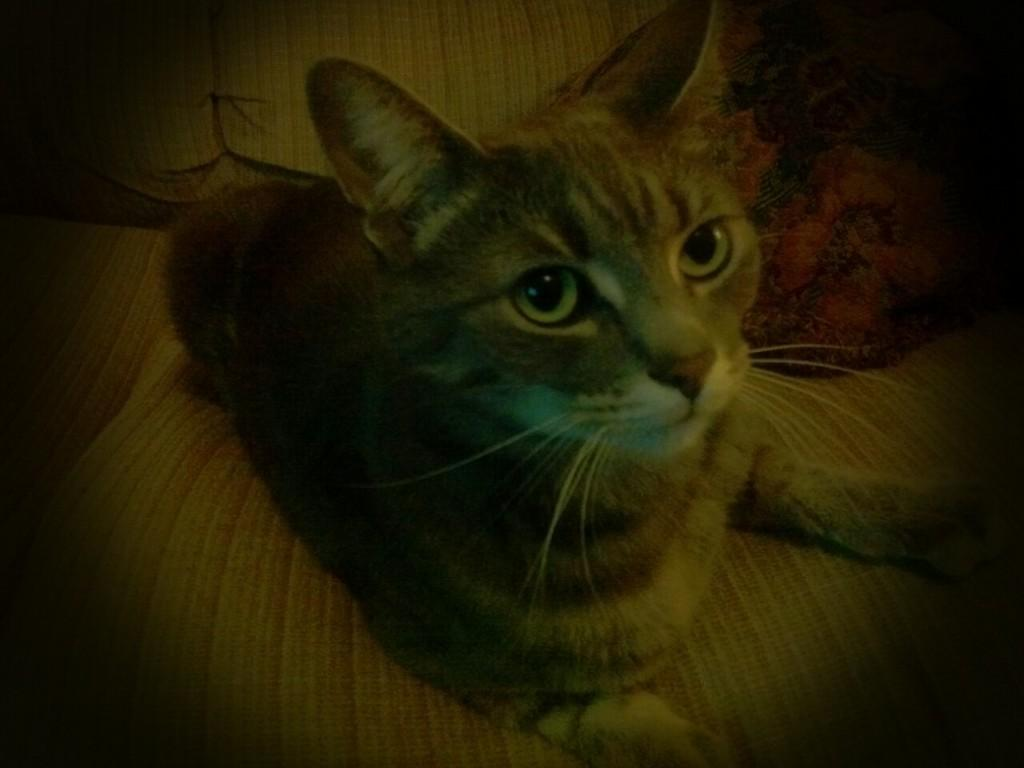What animal is in the picture? There is a cat in the picture. Where is the cat located? The cat is sitting on a couch. What else can be seen near the cat? There are pillows beside the cat. How many snakes are slithering on the floor in the image? There are no snakes present in the image; it features a cat sitting on a couch with pillows nearby. What type of picture is hanging on the wall behind the cat? The image does not provide information about any pictures hanging on the wall behind the cat. 